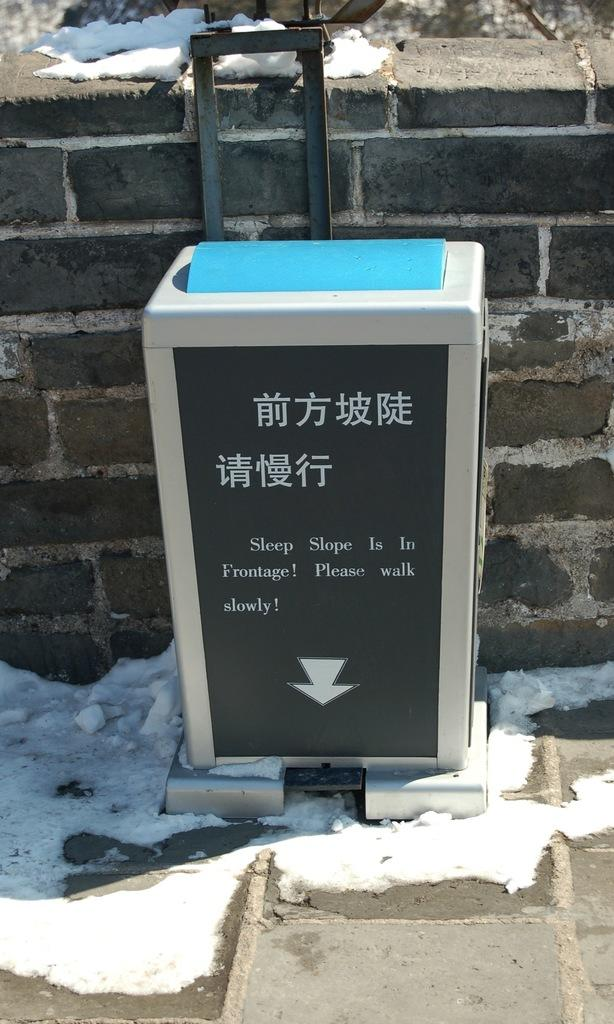<image>
Give a short and clear explanation of the subsequent image. An arrow points down with a warning to walk slowly above it. 